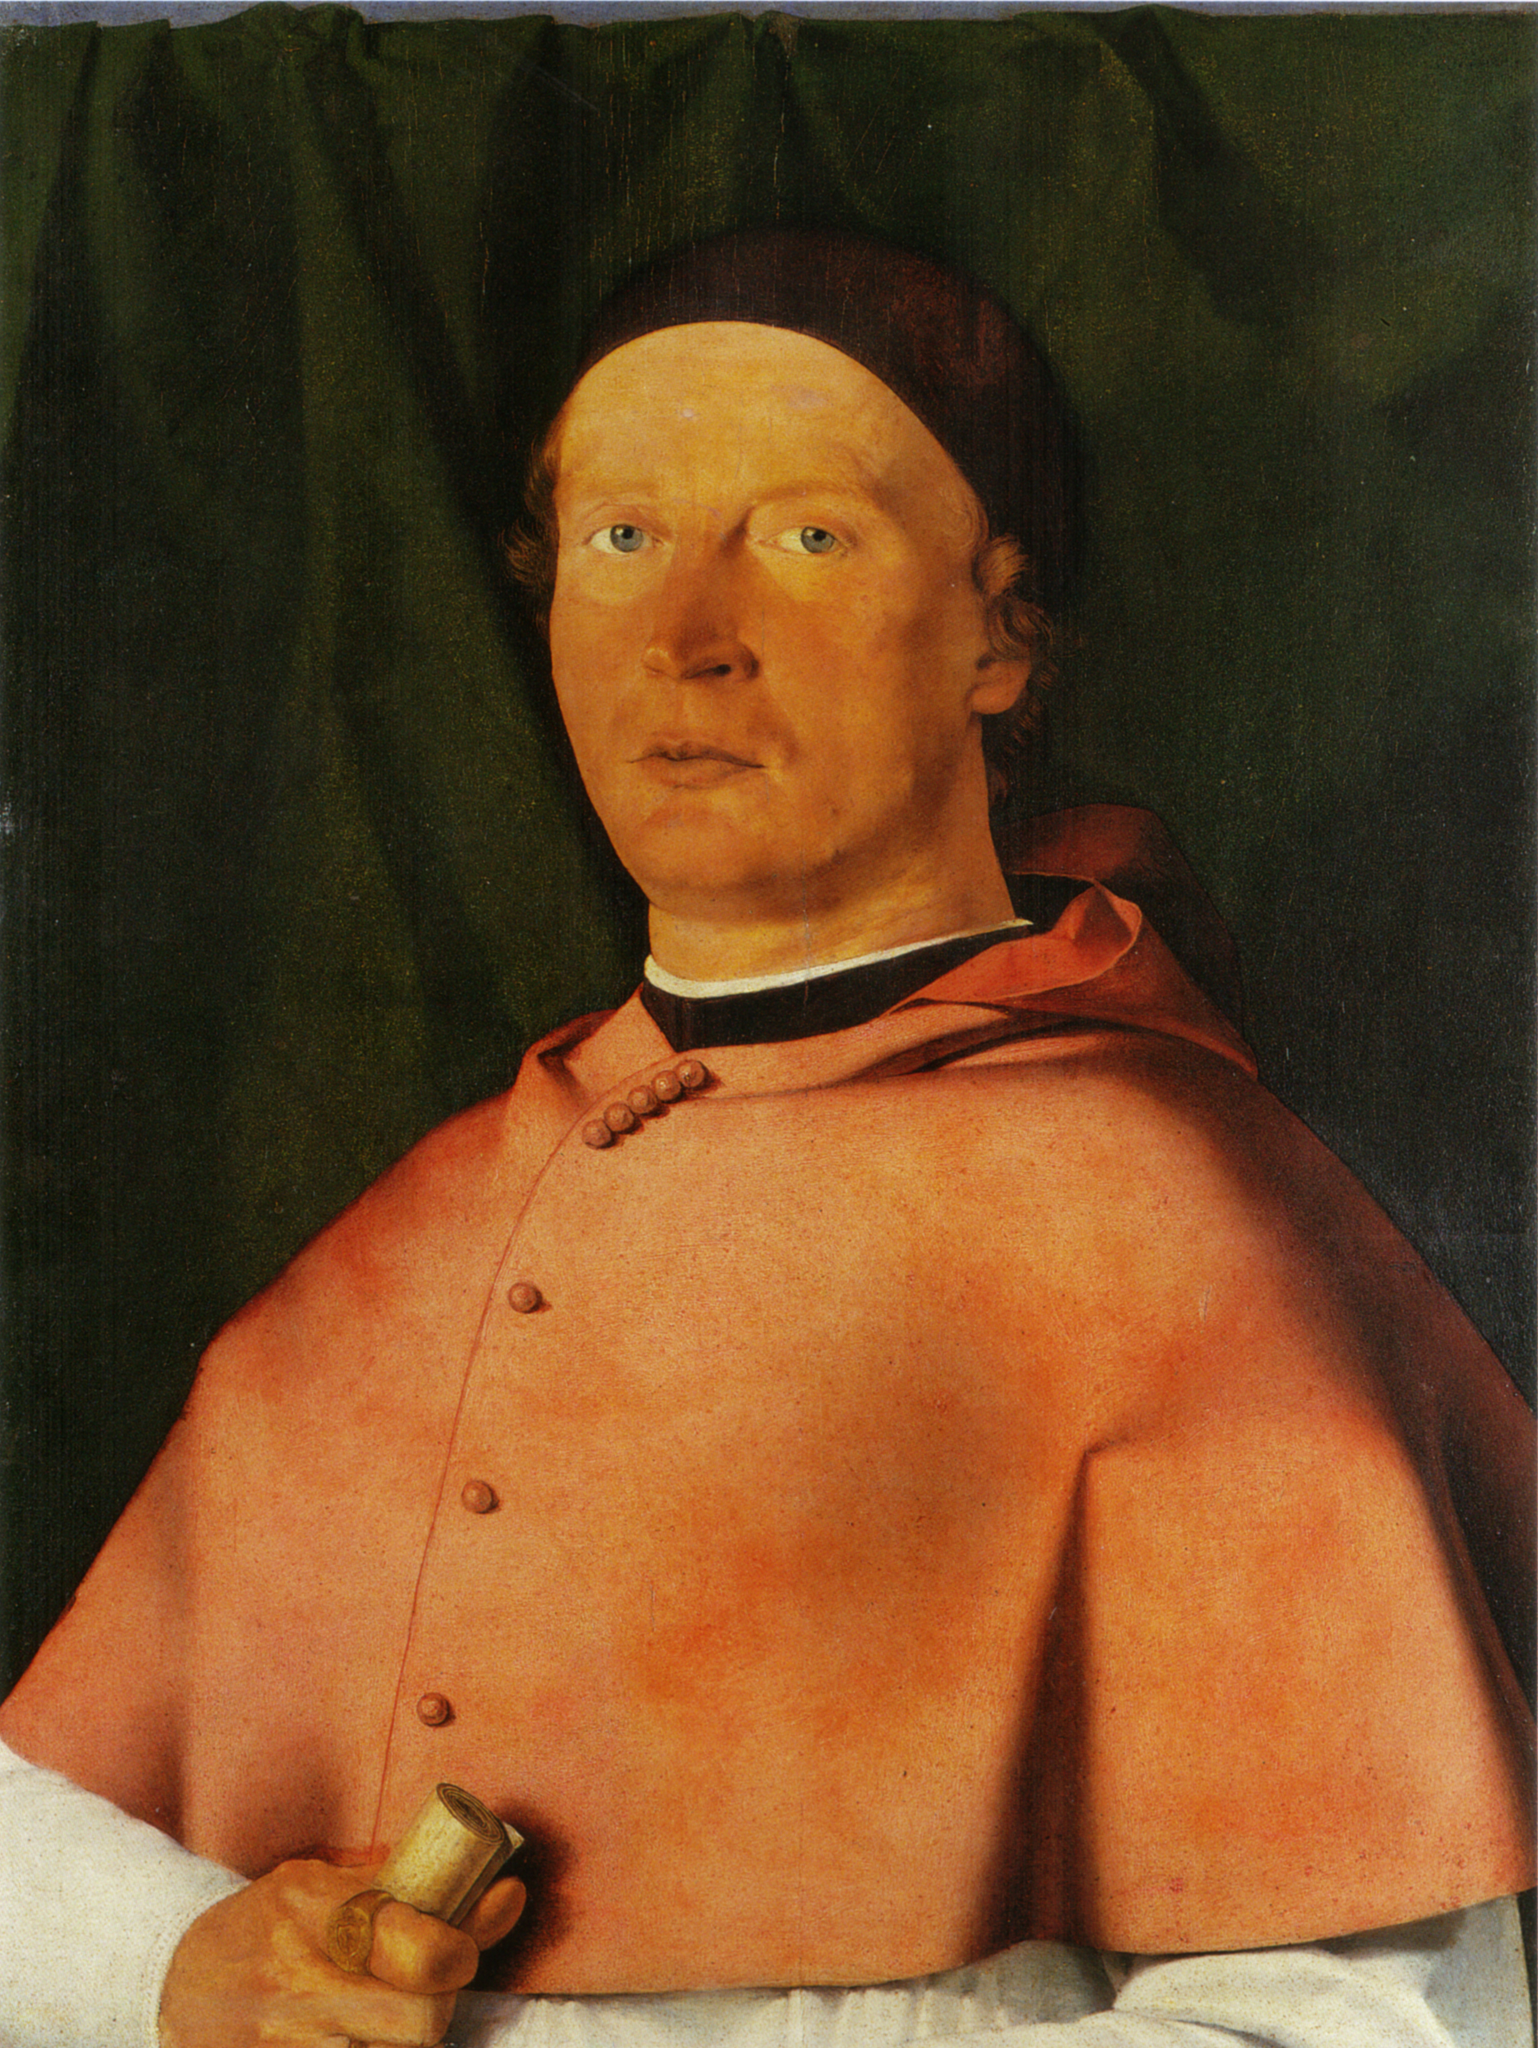Can you tell me more about the significance of the red robe in historical portraits? Certainly! The red robe in historical paintings often symbolizes power, status, and wealth. The color red was expensive to produce and thus commonly associated with royalty, nobility, or high-ranking church officials. In portraits, such as this one, featuring a figure in a red robe might indicate that the subject held a significant position in society or was intended to be seen as a person of importance and influence. 